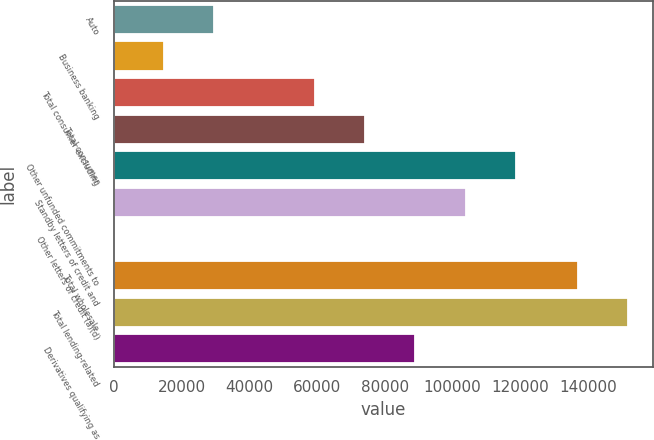Convert chart. <chart><loc_0><loc_0><loc_500><loc_500><bar_chart><fcel>Auto<fcel>Business banking<fcel>Total consumer excluding<fcel>Total consumer<fcel>Other unfunded commitments to<fcel>Standby letters of credit and<fcel>Other letters of credit (a)(d)<fcel>Total wholesale<fcel>Total lending-related<fcel>Derivatives qualifying as<nl><fcel>29730.6<fcel>14902.3<fcel>59387.2<fcel>74215.5<fcel>118700<fcel>103872<fcel>74<fcel>136919<fcel>151747<fcel>89043.8<nl></chart> 